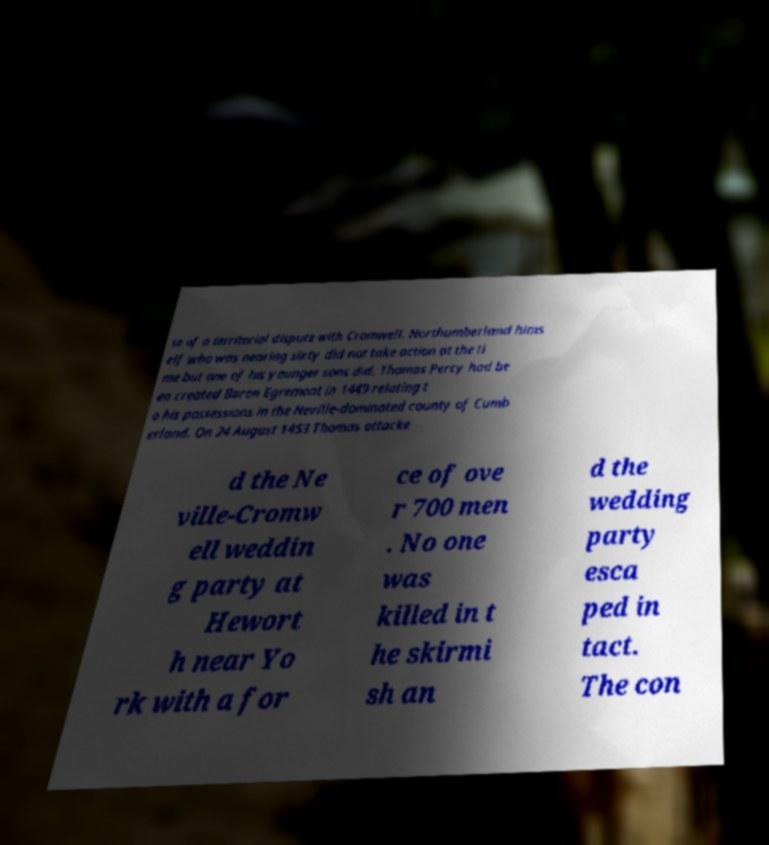Can you read and provide the text displayed in the image?This photo seems to have some interesting text. Can you extract and type it out for me? se of a territorial dispute with Cromwell. Northumberland hims elf who was nearing sixty did not take action at the ti me but one of his younger sons did. Thomas Percy had be en created Baron Egremont in 1449 relating t o his possessions in the Neville-dominated county of Cumb erland. On 24 August 1453 Thomas attacke d the Ne ville-Cromw ell weddin g party at Hewort h near Yo rk with a for ce of ove r 700 men . No one was killed in t he skirmi sh an d the wedding party esca ped in tact. The con 